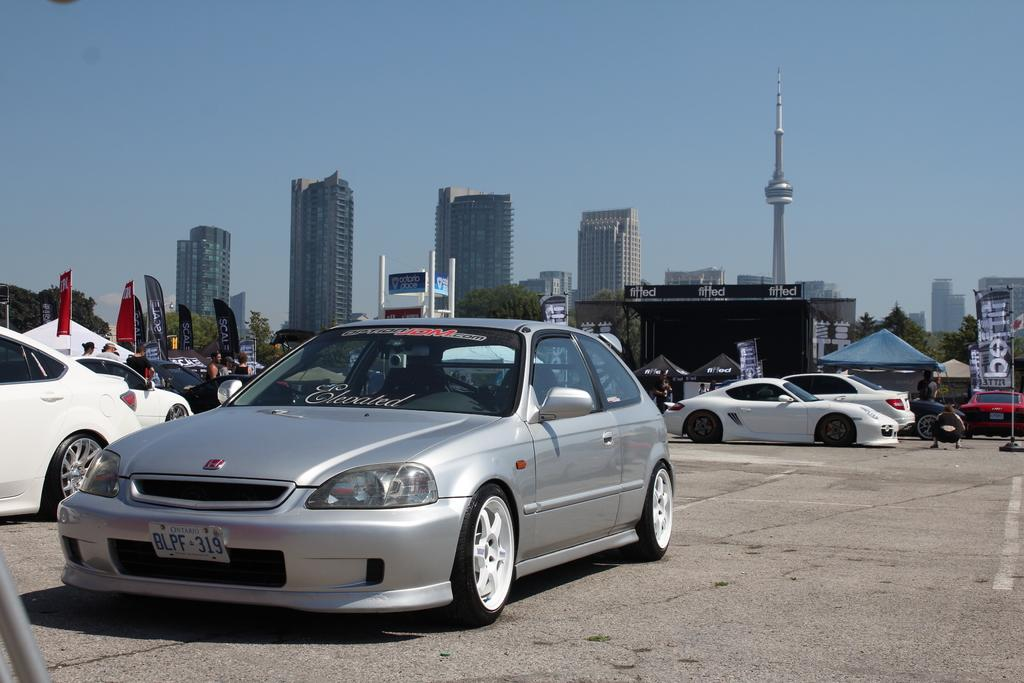What can be seen at the bottom of the image? There are vehicles on the road at the bottom of the image. Can you describe the vehicles in the image? The vehicles are in different colors. What is visible in the background of the image? There are flags, trees, buildings, and clouds in the blue sky in the background of the image. What type of books can be seen on the bridge in the image? There is no bridge or books present in the image. What is your opinion on the architectural design of the buildings in the image? The provided facts do not include any information about the architectural design of the buildings, so it is not possible to provide an opinion. 